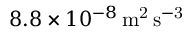Convert formula to latex. <formula><loc_0><loc_0><loc_500><loc_500>8 . 8 \times 1 0 ^ { - 8 } \, m ^ { 2 } \, s ^ { - 3 }</formula> 